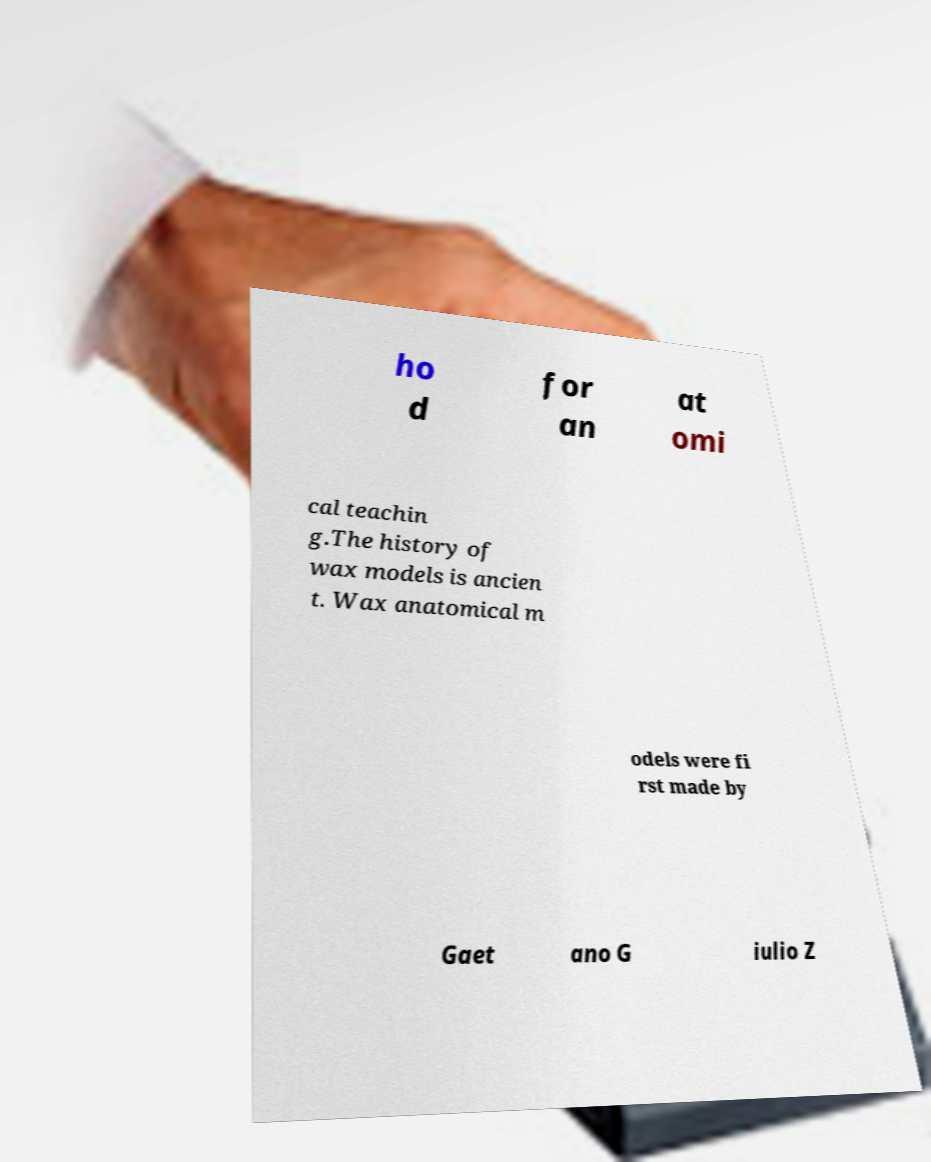I need the written content from this picture converted into text. Can you do that? ho d for an at omi cal teachin g.The history of wax models is ancien t. Wax anatomical m odels were fi rst made by Gaet ano G iulio Z 